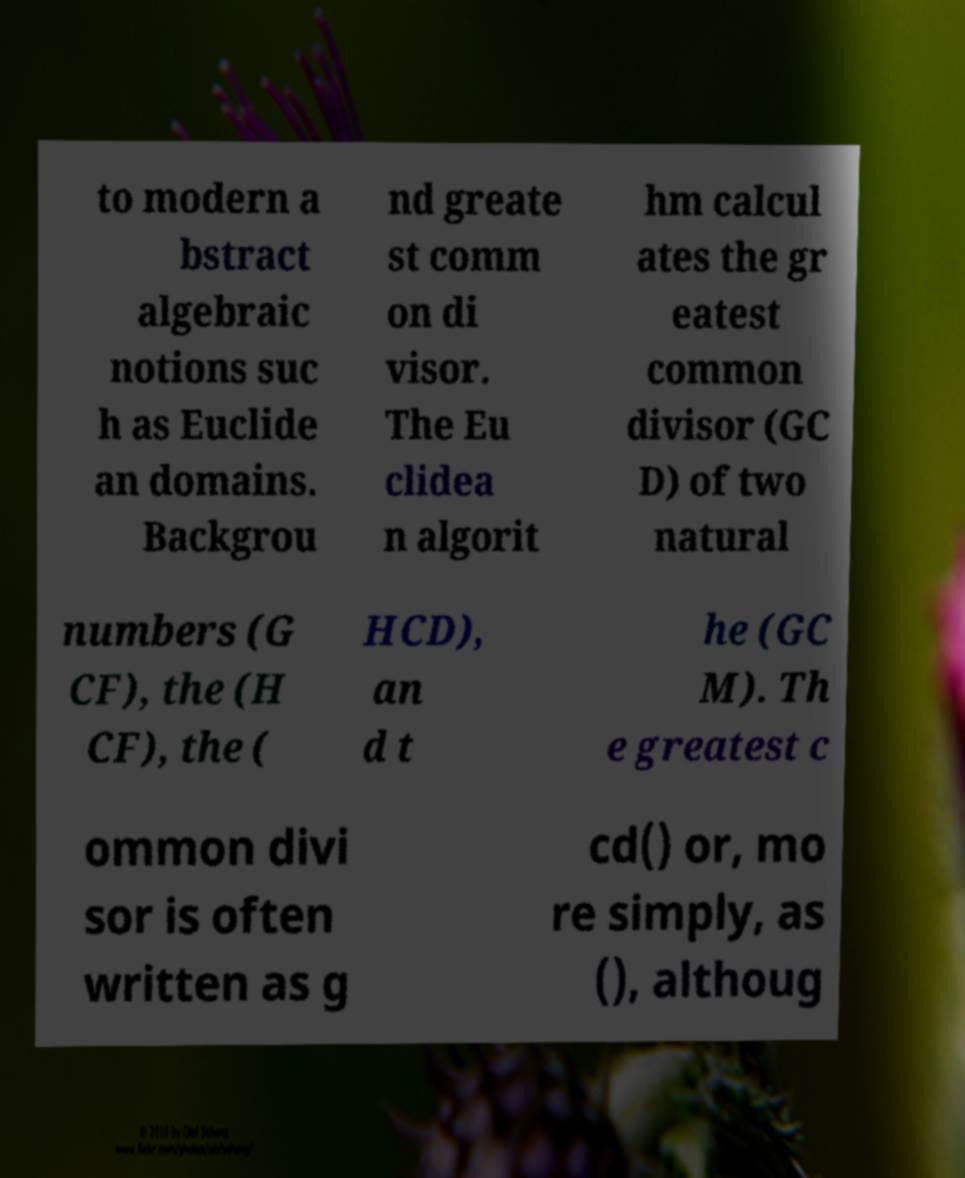I need the written content from this picture converted into text. Can you do that? to modern a bstract algebraic notions suc h as Euclide an domains. Backgrou nd greate st comm on di visor. The Eu clidea n algorit hm calcul ates the gr eatest common divisor (GC D) of two natural numbers (G CF), the (H CF), the ( HCD), an d t he (GC M). Th e greatest c ommon divi sor is often written as g cd() or, mo re simply, as (), althoug 